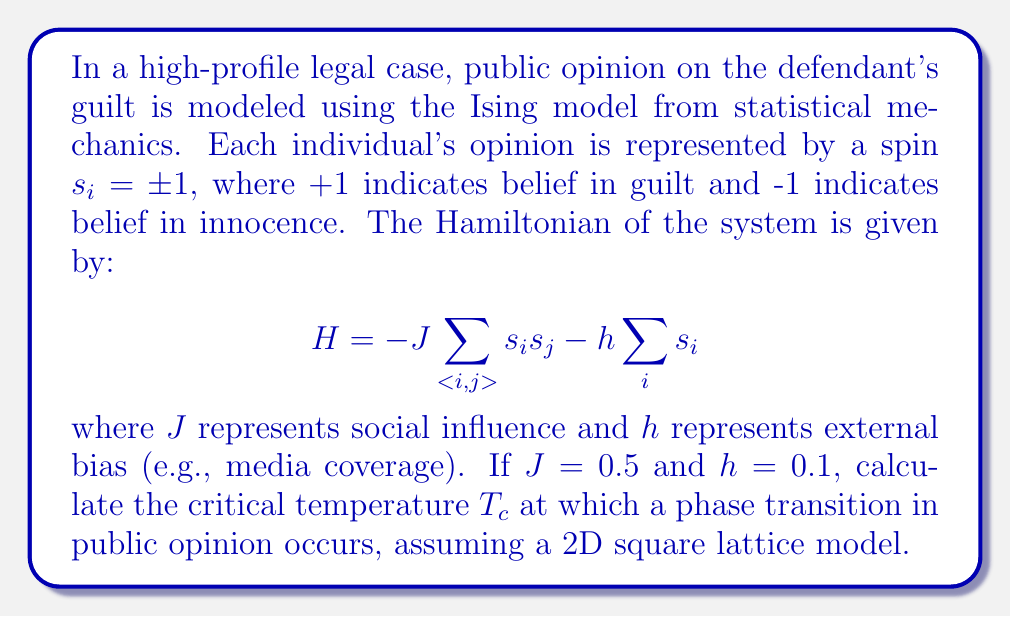Can you solve this math problem? To solve this problem, we'll use concepts from statistical mechanics and the Ising model:

1) The critical temperature $T_c$ for a 2D Ising model on a square lattice is given by the Onsager solution:

   $$\frac{k_BT_c}{J} = \frac{2}{\ln(1+\sqrt{2})} \approx 2.269$$

   where $k_B$ is the Boltzmann constant.

2) In this case, we're given $J = 0.5$. We need to solve for $T_c$:

   $$T_c = \frac{2J}{\ln(1+\sqrt{2})k_B}$$

3) Substituting $J = 0.5$:

   $$T_c = \frac{2(0.5)}{\ln(1+\sqrt{2})k_B} = \frac{1}{\ln(1+\sqrt{2})k_B}$$

4) The Boltzmann constant $k_B = 1.380649 \times 10^{-23}$ J/K. However, in many statistical mechanics problems, we often set $k_B = 1$ for simplicity. Let's do that here:

   $$T_c = \frac{1}{\ln(1+\sqrt{2})} \approx 1.1345$$

5) Note that the external field $h$ doesn't affect the critical temperature in the 2D Ising model, which is why we didn't use the given value of $h = 0.1$ in our calculation.

This critical temperature represents the point at which public opinion would undergo a phase transition, shifting from a disordered state (mixed opinions) to an ordered state (consensus) or vice versa.
Answer: $T_c \approx 1.1345$ (assuming $k_B = 1$) 